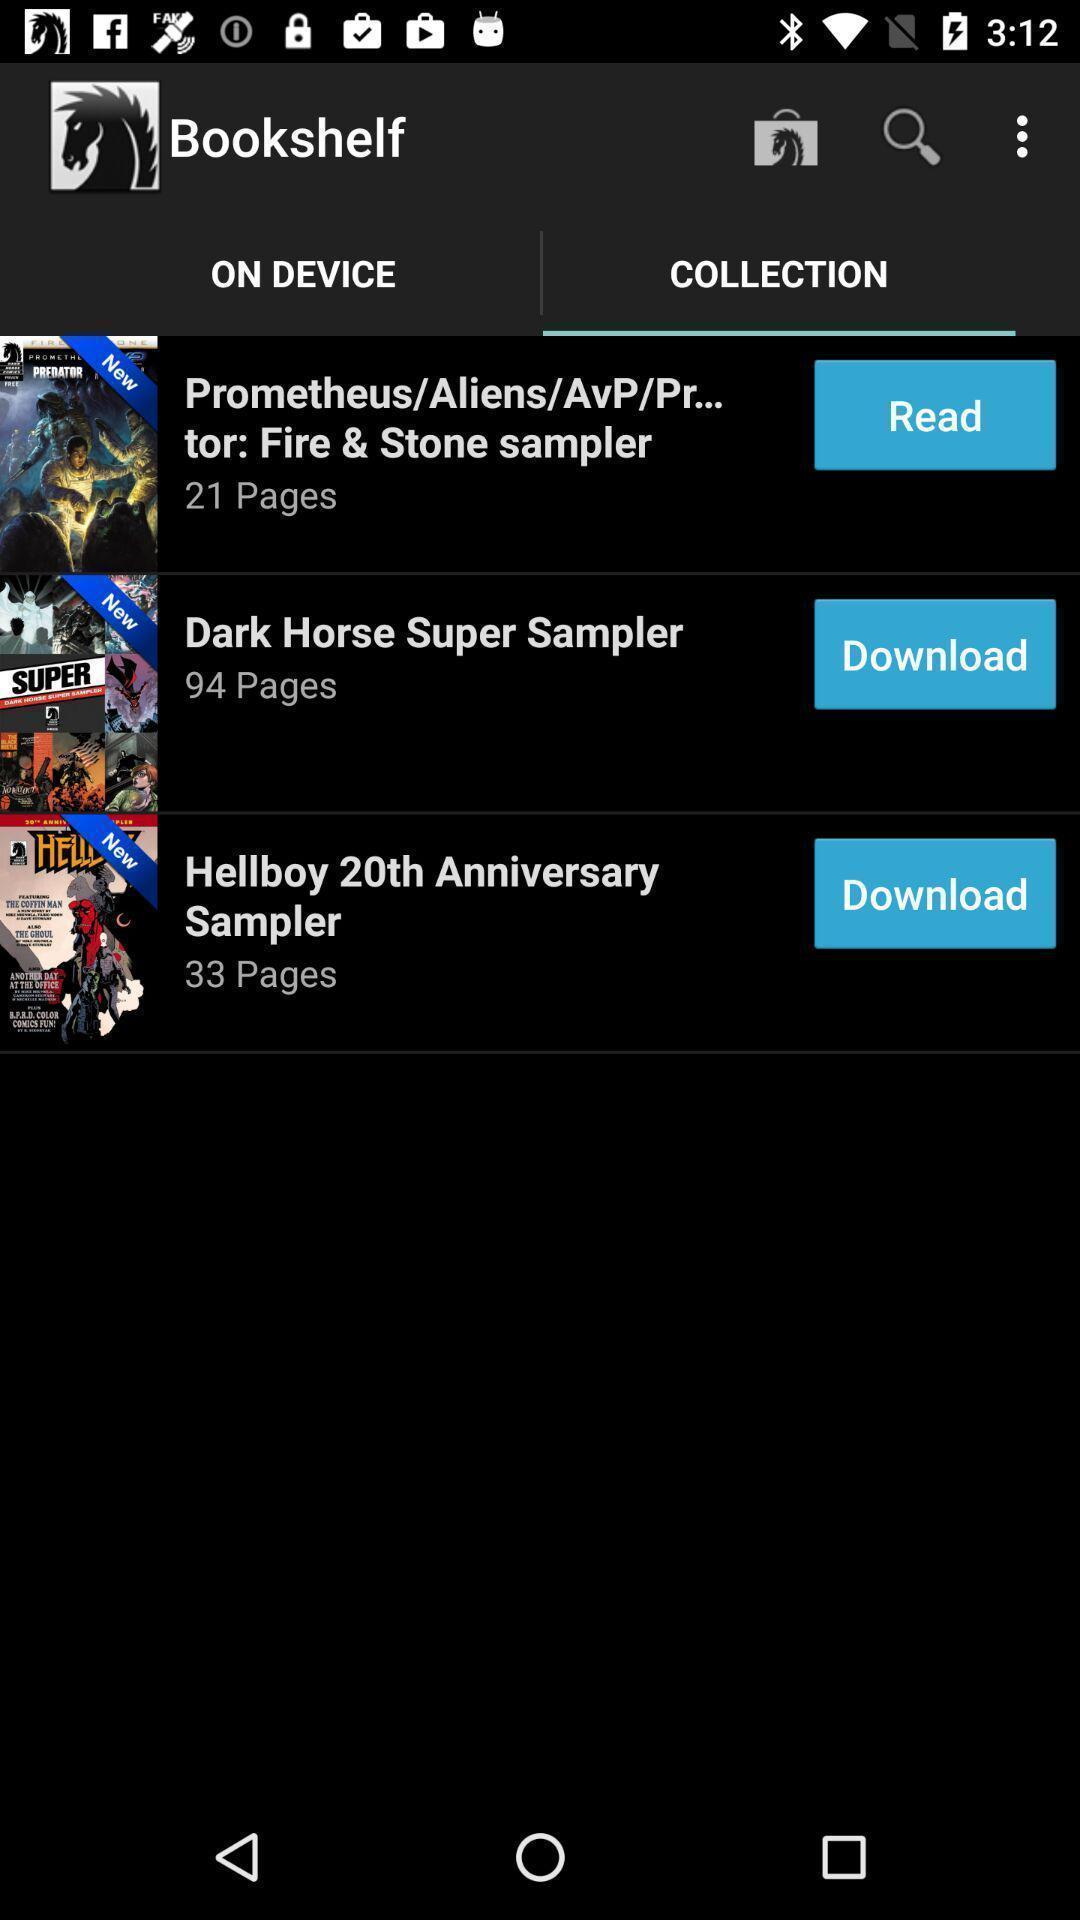What details can you identify in this image? Screen displaying the collections page. 